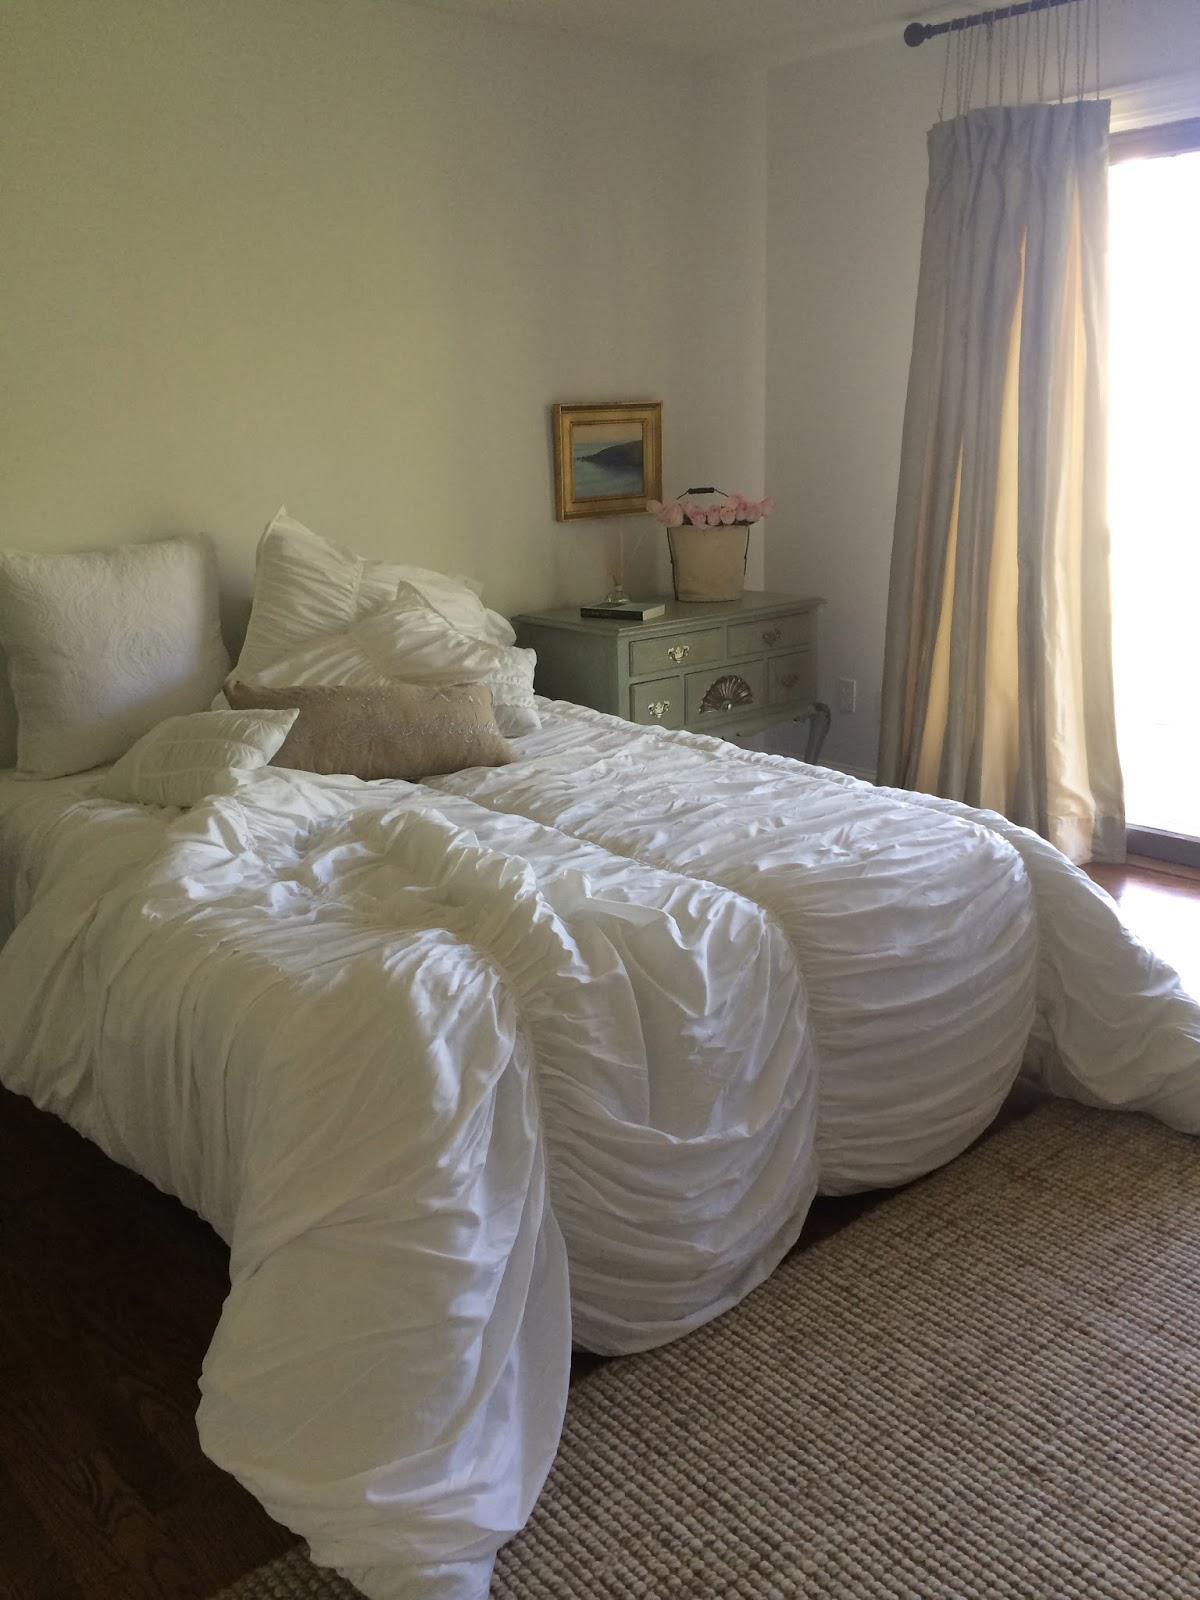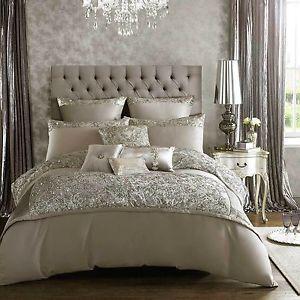The first image is the image on the left, the second image is the image on the right. Assess this claim about the two images: "On the wall above the headboard of one bed is a round decorative object.". Correct or not? Answer yes or no. No. 